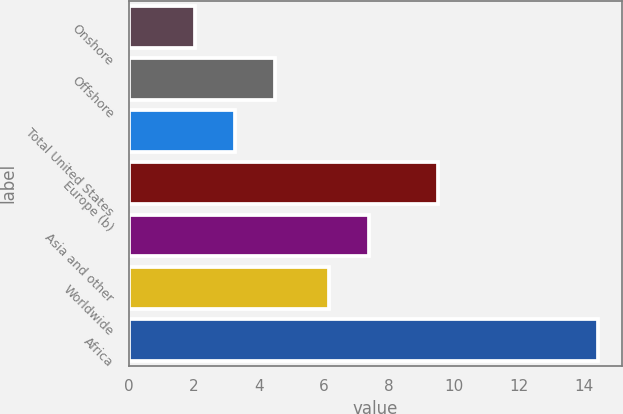<chart> <loc_0><loc_0><loc_500><loc_500><bar_chart><fcel>Onshore<fcel>Offshore<fcel>Total United States<fcel>Europe (b)<fcel>Asia and other<fcel>Worldwide<fcel>Africa<nl><fcel>2.02<fcel>4.5<fcel>3.26<fcel>9.5<fcel>7.4<fcel>6.16<fcel>14.45<nl></chart> 